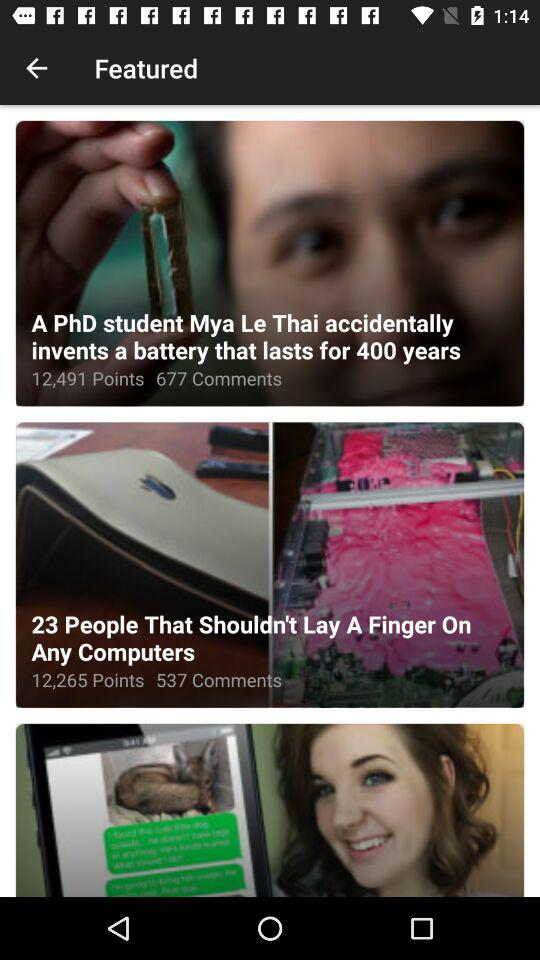How many comments are there for "A PhD student Mya Le Thai accidentally invents a battery"? There are 677 comments. 